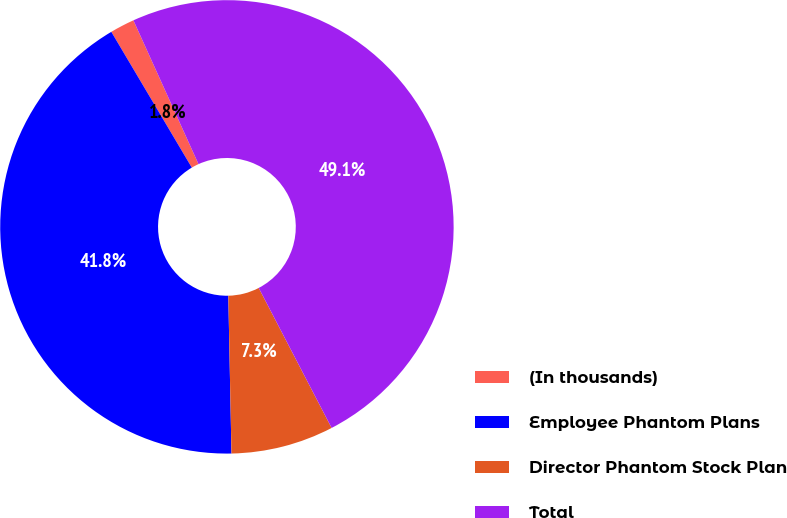Convert chart. <chart><loc_0><loc_0><loc_500><loc_500><pie_chart><fcel>(In thousands)<fcel>Employee Phantom Plans<fcel>Director Phantom Stock Plan<fcel>Total<nl><fcel>1.75%<fcel>41.8%<fcel>7.32%<fcel>49.12%<nl></chart> 